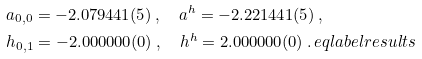Convert formula to latex. <formula><loc_0><loc_0><loc_500><loc_500>& a _ { 0 , 0 } = - 2 . 0 7 9 4 4 1 ( 5 ) \, , \quad a ^ { h } = - 2 . 2 2 1 4 4 1 ( 5 ) \, , \\ & h _ { 0 , 1 } = - 2 . 0 0 0 0 0 0 ( 0 ) \, , \quad h ^ { h } = 2 . 0 0 0 0 0 0 ( 0 ) \, . \ e q l a b e l { r e s u l t s }</formula> 